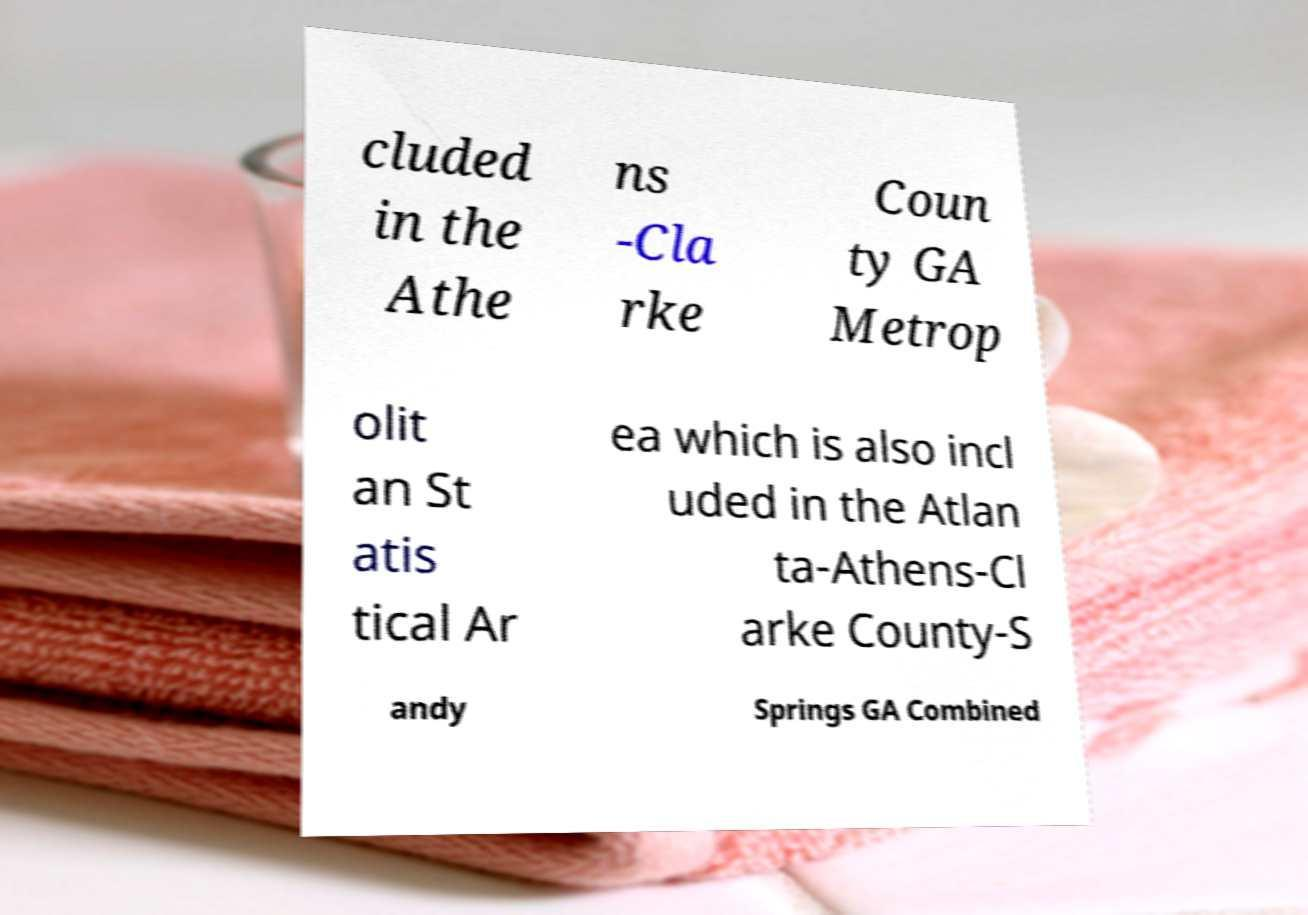What messages or text are displayed in this image? I need them in a readable, typed format. cluded in the Athe ns -Cla rke Coun ty GA Metrop olit an St atis tical Ar ea which is also incl uded in the Atlan ta-Athens-Cl arke County-S andy Springs GA Combined 